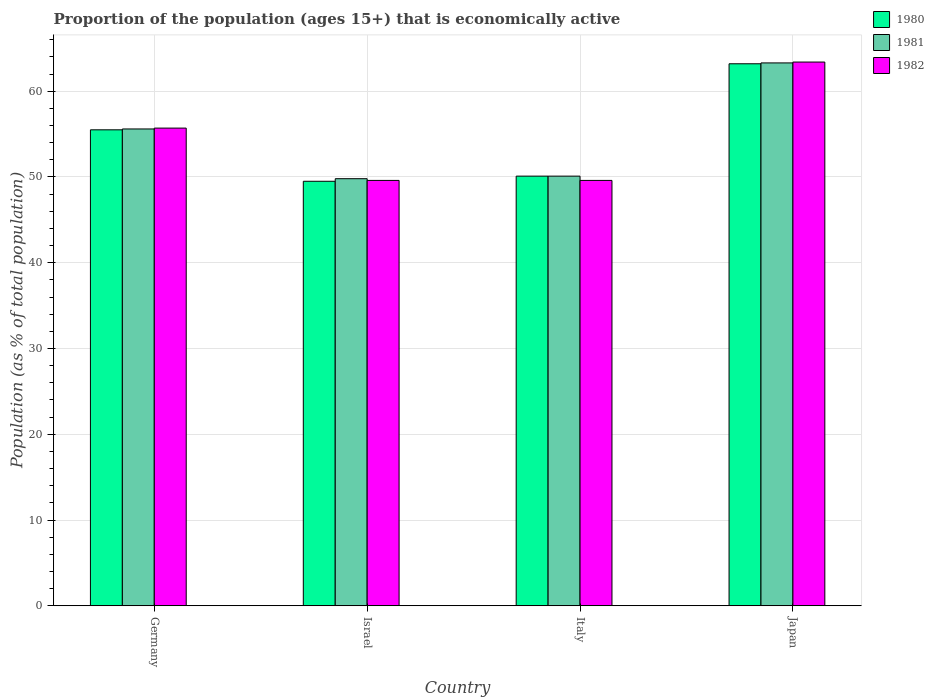Are the number of bars per tick equal to the number of legend labels?
Give a very brief answer. Yes. Are the number of bars on each tick of the X-axis equal?
Make the answer very short. Yes. How many bars are there on the 1st tick from the left?
Your response must be concise. 3. How many bars are there on the 1st tick from the right?
Provide a short and direct response. 3. What is the label of the 2nd group of bars from the left?
Give a very brief answer. Israel. What is the proportion of the population that is economically active in 1980 in Japan?
Provide a succinct answer. 63.2. Across all countries, what is the maximum proportion of the population that is economically active in 1981?
Provide a short and direct response. 63.3. Across all countries, what is the minimum proportion of the population that is economically active in 1980?
Give a very brief answer. 49.5. In which country was the proportion of the population that is economically active in 1981 maximum?
Your answer should be very brief. Japan. In which country was the proportion of the population that is economically active in 1981 minimum?
Your answer should be compact. Israel. What is the total proportion of the population that is economically active in 1982 in the graph?
Your answer should be very brief. 218.3. What is the difference between the proportion of the population that is economically active in 1980 in Germany and that in Japan?
Your answer should be very brief. -7.7. What is the difference between the proportion of the population that is economically active in 1982 in Japan and the proportion of the population that is economically active in 1980 in Israel?
Offer a very short reply. 13.9. What is the average proportion of the population that is economically active in 1982 per country?
Give a very brief answer. 54.57. What is the difference between the proportion of the population that is economically active of/in 1981 and proportion of the population that is economically active of/in 1980 in Israel?
Offer a terse response. 0.3. In how many countries, is the proportion of the population that is economically active in 1981 greater than 16 %?
Provide a succinct answer. 4. What is the ratio of the proportion of the population that is economically active in 1981 in Germany to that in Israel?
Your answer should be compact. 1.12. What is the difference between the highest and the lowest proportion of the population that is economically active in 1982?
Make the answer very short. 13.8. In how many countries, is the proportion of the population that is economically active in 1981 greater than the average proportion of the population that is economically active in 1981 taken over all countries?
Make the answer very short. 2. Is the sum of the proportion of the population that is economically active in 1982 in Germany and Japan greater than the maximum proportion of the population that is economically active in 1980 across all countries?
Make the answer very short. Yes. What does the 2nd bar from the right in Italy represents?
Provide a short and direct response. 1981. How many bars are there?
Ensure brevity in your answer.  12. Are all the bars in the graph horizontal?
Provide a short and direct response. No. How many countries are there in the graph?
Provide a short and direct response. 4. What is the difference between two consecutive major ticks on the Y-axis?
Offer a very short reply. 10. Are the values on the major ticks of Y-axis written in scientific E-notation?
Your answer should be compact. No. What is the title of the graph?
Offer a very short reply. Proportion of the population (ages 15+) that is economically active. Does "1973" appear as one of the legend labels in the graph?
Ensure brevity in your answer.  No. What is the label or title of the X-axis?
Provide a short and direct response. Country. What is the label or title of the Y-axis?
Provide a succinct answer. Population (as % of total population). What is the Population (as % of total population) of 1980 in Germany?
Your response must be concise. 55.5. What is the Population (as % of total population) of 1981 in Germany?
Offer a terse response. 55.6. What is the Population (as % of total population) of 1982 in Germany?
Your response must be concise. 55.7. What is the Population (as % of total population) of 1980 in Israel?
Provide a succinct answer. 49.5. What is the Population (as % of total population) of 1981 in Israel?
Keep it short and to the point. 49.8. What is the Population (as % of total population) of 1982 in Israel?
Provide a succinct answer. 49.6. What is the Population (as % of total population) in 1980 in Italy?
Make the answer very short. 50.1. What is the Population (as % of total population) in 1981 in Italy?
Your response must be concise. 50.1. What is the Population (as % of total population) in 1982 in Italy?
Your response must be concise. 49.6. What is the Population (as % of total population) of 1980 in Japan?
Keep it short and to the point. 63.2. What is the Population (as % of total population) of 1981 in Japan?
Your response must be concise. 63.3. What is the Population (as % of total population) in 1982 in Japan?
Provide a succinct answer. 63.4. Across all countries, what is the maximum Population (as % of total population) in 1980?
Keep it short and to the point. 63.2. Across all countries, what is the maximum Population (as % of total population) of 1981?
Your answer should be compact. 63.3. Across all countries, what is the maximum Population (as % of total population) of 1982?
Offer a terse response. 63.4. Across all countries, what is the minimum Population (as % of total population) of 1980?
Offer a very short reply. 49.5. Across all countries, what is the minimum Population (as % of total population) in 1981?
Ensure brevity in your answer.  49.8. Across all countries, what is the minimum Population (as % of total population) in 1982?
Provide a succinct answer. 49.6. What is the total Population (as % of total population) of 1980 in the graph?
Keep it short and to the point. 218.3. What is the total Population (as % of total population) in 1981 in the graph?
Offer a very short reply. 218.8. What is the total Population (as % of total population) of 1982 in the graph?
Keep it short and to the point. 218.3. What is the difference between the Population (as % of total population) of 1980 in Germany and that in Israel?
Provide a succinct answer. 6. What is the difference between the Population (as % of total population) of 1982 in Germany and that in Israel?
Offer a very short reply. 6.1. What is the difference between the Population (as % of total population) in 1980 in Germany and that in Italy?
Your answer should be compact. 5.4. What is the difference between the Population (as % of total population) in 1981 in Germany and that in Italy?
Offer a terse response. 5.5. What is the difference between the Population (as % of total population) of 1982 in Germany and that in Japan?
Your response must be concise. -7.7. What is the difference between the Population (as % of total population) in 1980 in Israel and that in Italy?
Make the answer very short. -0.6. What is the difference between the Population (as % of total population) in 1981 in Israel and that in Italy?
Your response must be concise. -0.3. What is the difference between the Population (as % of total population) of 1980 in Israel and that in Japan?
Provide a short and direct response. -13.7. What is the difference between the Population (as % of total population) in 1980 in Italy and that in Japan?
Your answer should be compact. -13.1. What is the difference between the Population (as % of total population) of 1982 in Italy and that in Japan?
Your answer should be compact. -13.8. What is the difference between the Population (as % of total population) of 1980 in Germany and the Population (as % of total population) of 1981 in Israel?
Your answer should be compact. 5.7. What is the difference between the Population (as % of total population) in 1980 in Germany and the Population (as % of total population) in 1982 in Israel?
Provide a short and direct response. 5.9. What is the difference between the Population (as % of total population) of 1980 in Germany and the Population (as % of total population) of 1981 in Italy?
Offer a terse response. 5.4. What is the difference between the Population (as % of total population) in 1981 in Germany and the Population (as % of total population) in 1982 in Italy?
Your response must be concise. 6. What is the difference between the Population (as % of total population) in 1981 in Israel and the Population (as % of total population) in 1982 in Italy?
Offer a very short reply. 0.2. What is the difference between the Population (as % of total population) in 1980 in Israel and the Population (as % of total population) in 1981 in Japan?
Offer a very short reply. -13.8. What is the difference between the Population (as % of total population) in 1980 in Israel and the Population (as % of total population) in 1982 in Japan?
Your answer should be very brief. -13.9. What is the difference between the Population (as % of total population) of 1981 in Israel and the Population (as % of total population) of 1982 in Japan?
Provide a short and direct response. -13.6. What is the difference between the Population (as % of total population) of 1980 in Italy and the Population (as % of total population) of 1981 in Japan?
Ensure brevity in your answer.  -13.2. What is the difference between the Population (as % of total population) of 1980 in Italy and the Population (as % of total population) of 1982 in Japan?
Make the answer very short. -13.3. What is the difference between the Population (as % of total population) in 1981 in Italy and the Population (as % of total population) in 1982 in Japan?
Offer a very short reply. -13.3. What is the average Population (as % of total population) in 1980 per country?
Provide a succinct answer. 54.58. What is the average Population (as % of total population) of 1981 per country?
Your response must be concise. 54.7. What is the average Population (as % of total population) in 1982 per country?
Provide a short and direct response. 54.58. What is the difference between the Population (as % of total population) in 1980 and Population (as % of total population) in 1981 in Germany?
Give a very brief answer. -0.1. What is the difference between the Population (as % of total population) in 1980 and Population (as % of total population) in 1982 in Germany?
Your answer should be very brief. -0.2. What is the difference between the Population (as % of total population) in 1980 and Population (as % of total population) in 1981 in Israel?
Give a very brief answer. -0.3. What is the ratio of the Population (as % of total population) of 1980 in Germany to that in Israel?
Provide a succinct answer. 1.12. What is the ratio of the Population (as % of total population) of 1981 in Germany to that in Israel?
Offer a terse response. 1.12. What is the ratio of the Population (as % of total population) in 1982 in Germany to that in Israel?
Give a very brief answer. 1.12. What is the ratio of the Population (as % of total population) of 1980 in Germany to that in Italy?
Offer a very short reply. 1.11. What is the ratio of the Population (as % of total population) of 1981 in Germany to that in Italy?
Ensure brevity in your answer.  1.11. What is the ratio of the Population (as % of total population) of 1982 in Germany to that in Italy?
Ensure brevity in your answer.  1.12. What is the ratio of the Population (as % of total population) in 1980 in Germany to that in Japan?
Make the answer very short. 0.88. What is the ratio of the Population (as % of total population) of 1981 in Germany to that in Japan?
Ensure brevity in your answer.  0.88. What is the ratio of the Population (as % of total population) of 1982 in Germany to that in Japan?
Offer a very short reply. 0.88. What is the ratio of the Population (as % of total population) in 1982 in Israel to that in Italy?
Your answer should be compact. 1. What is the ratio of the Population (as % of total population) in 1980 in Israel to that in Japan?
Give a very brief answer. 0.78. What is the ratio of the Population (as % of total population) in 1981 in Israel to that in Japan?
Keep it short and to the point. 0.79. What is the ratio of the Population (as % of total population) of 1982 in Israel to that in Japan?
Ensure brevity in your answer.  0.78. What is the ratio of the Population (as % of total population) of 1980 in Italy to that in Japan?
Offer a terse response. 0.79. What is the ratio of the Population (as % of total population) in 1981 in Italy to that in Japan?
Provide a succinct answer. 0.79. What is the ratio of the Population (as % of total population) of 1982 in Italy to that in Japan?
Your answer should be compact. 0.78. What is the difference between the highest and the second highest Population (as % of total population) of 1982?
Your response must be concise. 7.7. What is the difference between the highest and the lowest Population (as % of total population) in 1980?
Make the answer very short. 13.7. What is the difference between the highest and the lowest Population (as % of total population) of 1982?
Ensure brevity in your answer.  13.8. 